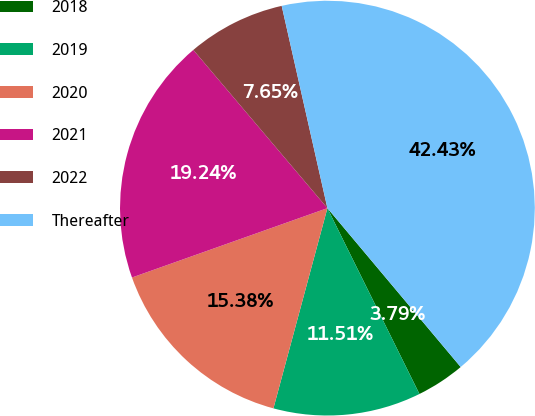Convert chart. <chart><loc_0><loc_0><loc_500><loc_500><pie_chart><fcel>2018<fcel>2019<fcel>2020<fcel>2021<fcel>2022<fcel>Thereafter<nl><fcel>3.79%<fcel>11.51%<fcel>15.38%<fcel>19.24%<fcel>7.65%<fcel>42.43%<nl></chart> 